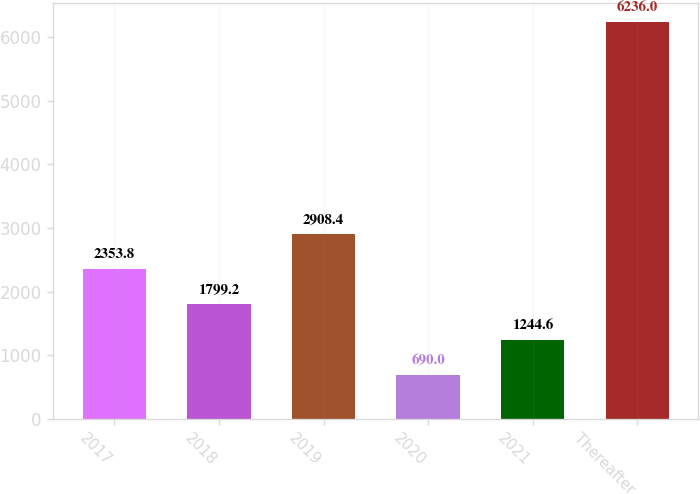Convert chart. <chart><loc_0><loc_0><loc_500><loc_500><bar_chart><fcel>2017<fcel>2018<fcel>2019<fcel>2020<fcel>2021<fcel>Thereafter<nl><fcel>2353.8<fcel>1799.2<fcel>2908.4<fcel>690<fcel>1244.6<fcel>6236<nl></chart> 